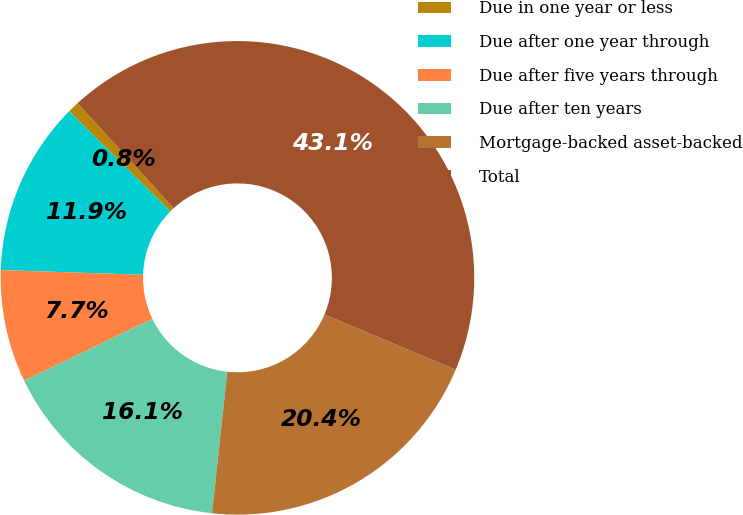<chart> <loc_0><loc_0><loc_500><loc_500><pie_chart><fcel>Due in one year or less<fcel>Due after one year through<fcel>Due after five years through<fcel>Due after ten years<fcel>Mortgage-backed asset-backed<fcel>Total<nl><fcel>0.78%<fcel>11.9%<fcel>7.67%<fcel>16.14%<fcel>20.37%<fcel>43.14%<nl></chart> 